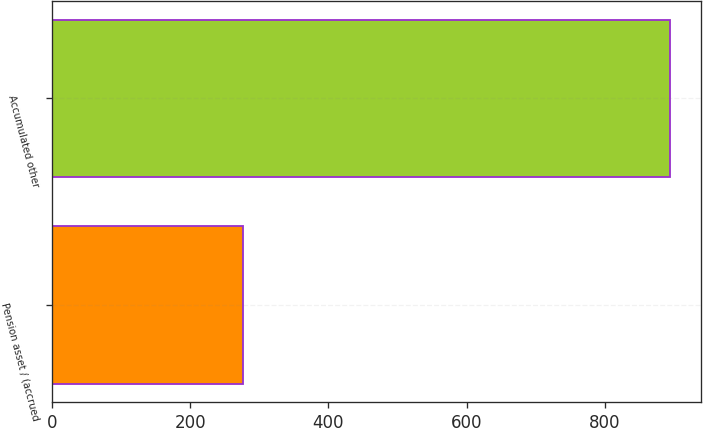<chart> <loc_0><loc_0><loc_500><loc_500><bar_chart><fcel>Pension asset / (accrued<fcel>Accumulated other<nl><fcel>276<fcel>895<nl></chart> 